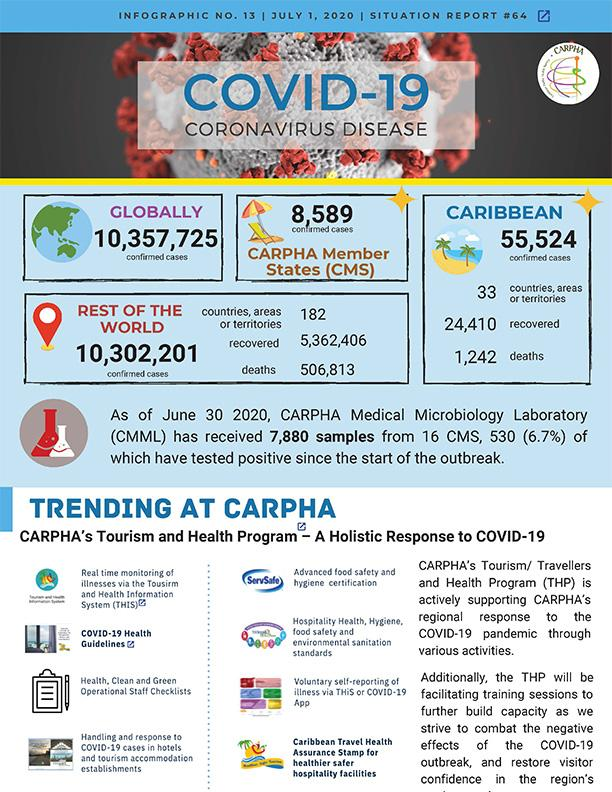Outline some significant characteristics in this image. As of July 1, 2020, a total of 1,242 deaths related to Covid-19 were reported in the Caribbean region. As of July 1, 2020, the global total number of confirmed COVID-19 cases was 10,357,725. As of July 1, 2020, a total of 8,589 confirmed COVID-19 cases had been reported in the CARPHA Member States. As of July 1, 2020, a total of 506,813 deaths from Covid-19 were reported in countries outside of China. As of July 1, 2020, a total of 24,410 COVID-19 cases have been reported and recovered in the Caribbean region. 